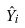<formula> <loc_0><loc_0><loc_500><loc_500>\hat { Y } _ { i }</formula> 